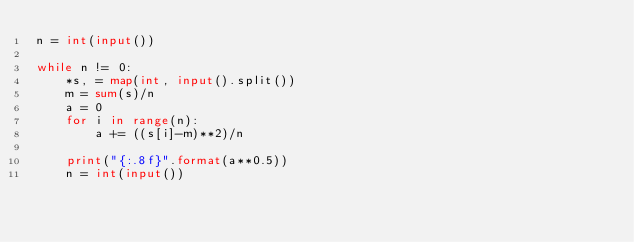<code> <loc_0><loc_0><loc_500><loc_500><_Python_>n = int(input())

while n != 0:
    *s, = map(int, input().split())
    m = sum(s)/n
    a = 0
    for i in range(n):
        a += ((s[i]-m)**2)/n

    print("{:.8f}".format(a**0.5))
    n = int(input())
</code> 